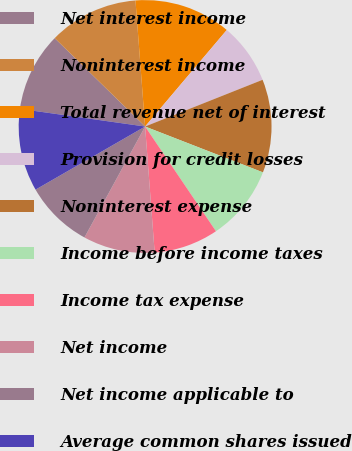Convert chart. <chart><loc_0><loc_0><loc_500><loc_500><pie_chart><fcel>Net interest income<fcel>Noninterest income<fcel>Total revenue net of interest<fcel>Provision for credit losses<fcel>Noninterest expense<fcel>Income before income taxes<fcel>Income tax expense<fcel>Net income<fcel>Net income applicable to<fcel>Average common shares issued<nl><fcel>10.09%<fcel>11.47%<fcel>12.39%<fcel>7.8%<fcel>11.93%<fcel>9.63%<fcel>8.26%<fcel>9.17%<fcel>8.72%<fcel>10.55%<nl></chart> 